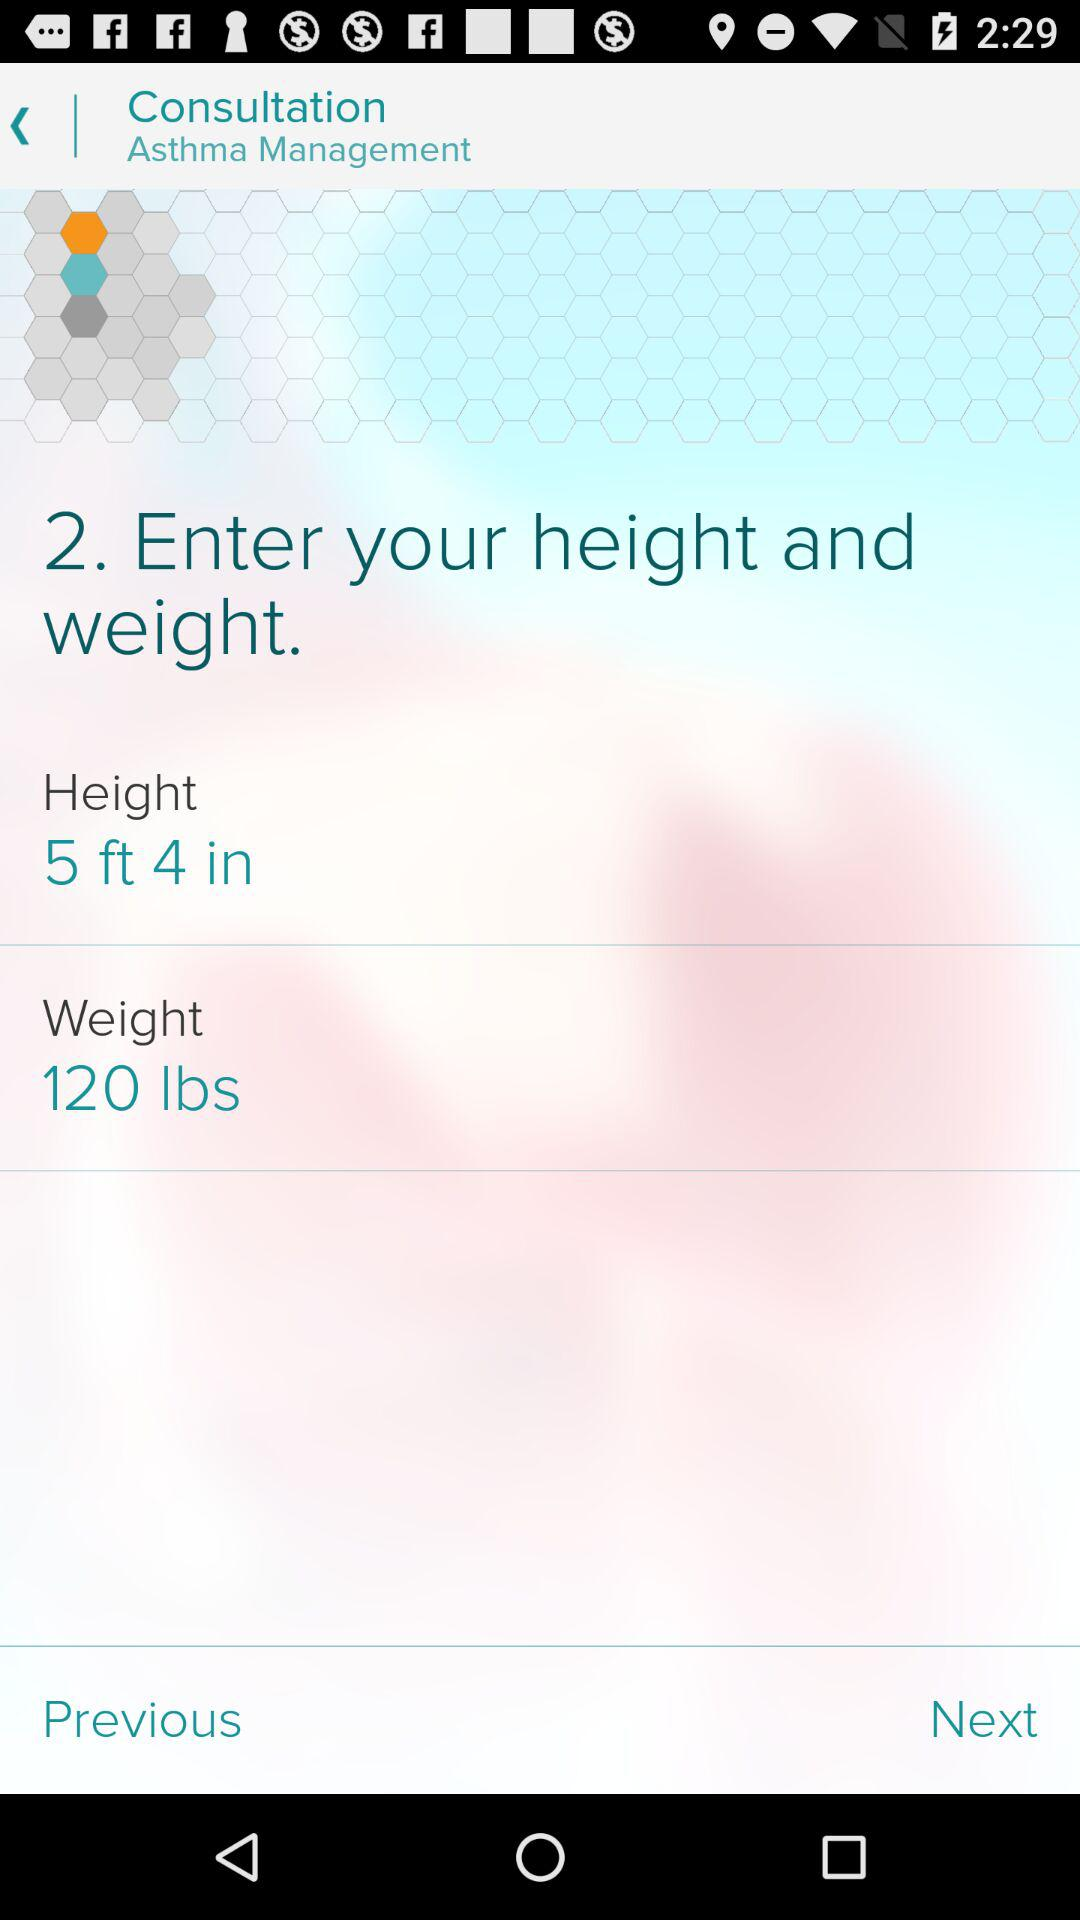What is the weight? The weight is 120 lbs. 